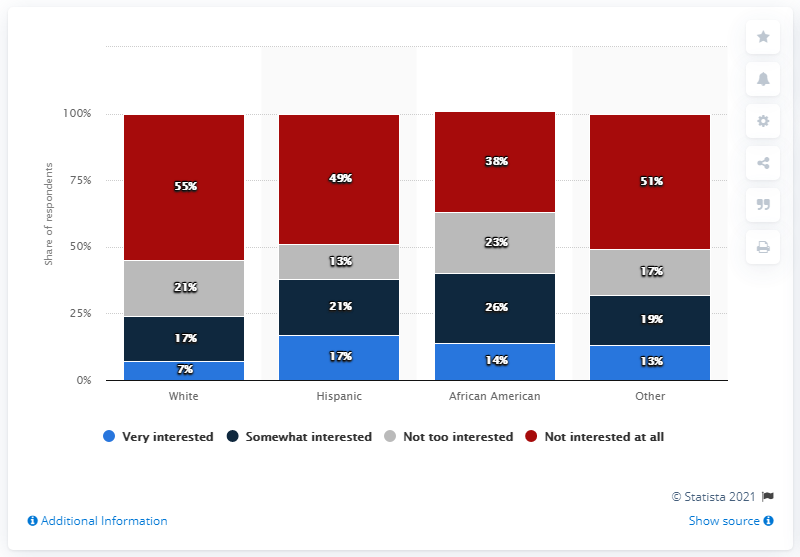How many people are very interested in soccer in the Hispanic race? The bar graph shown in the image indicates that 49% of Hispanic respondents are very interested in soccer. However, without specific data on the total number of respondents or the broader Hispanic population, we cannot determine an exact number of individuals. 